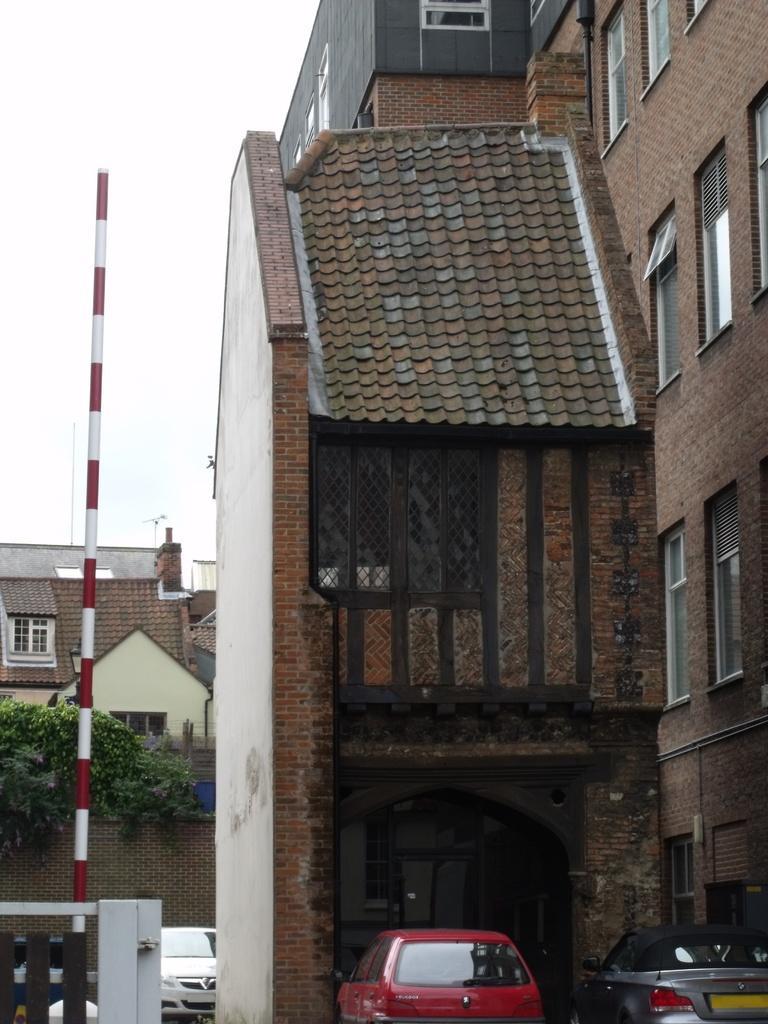Describe this image in one or two sentences. This is an outside view. At the bottom there are few cars. On the left side there is a pole and a tree. In the background, I can see the buildings. At the top of the image I can see the sky. 